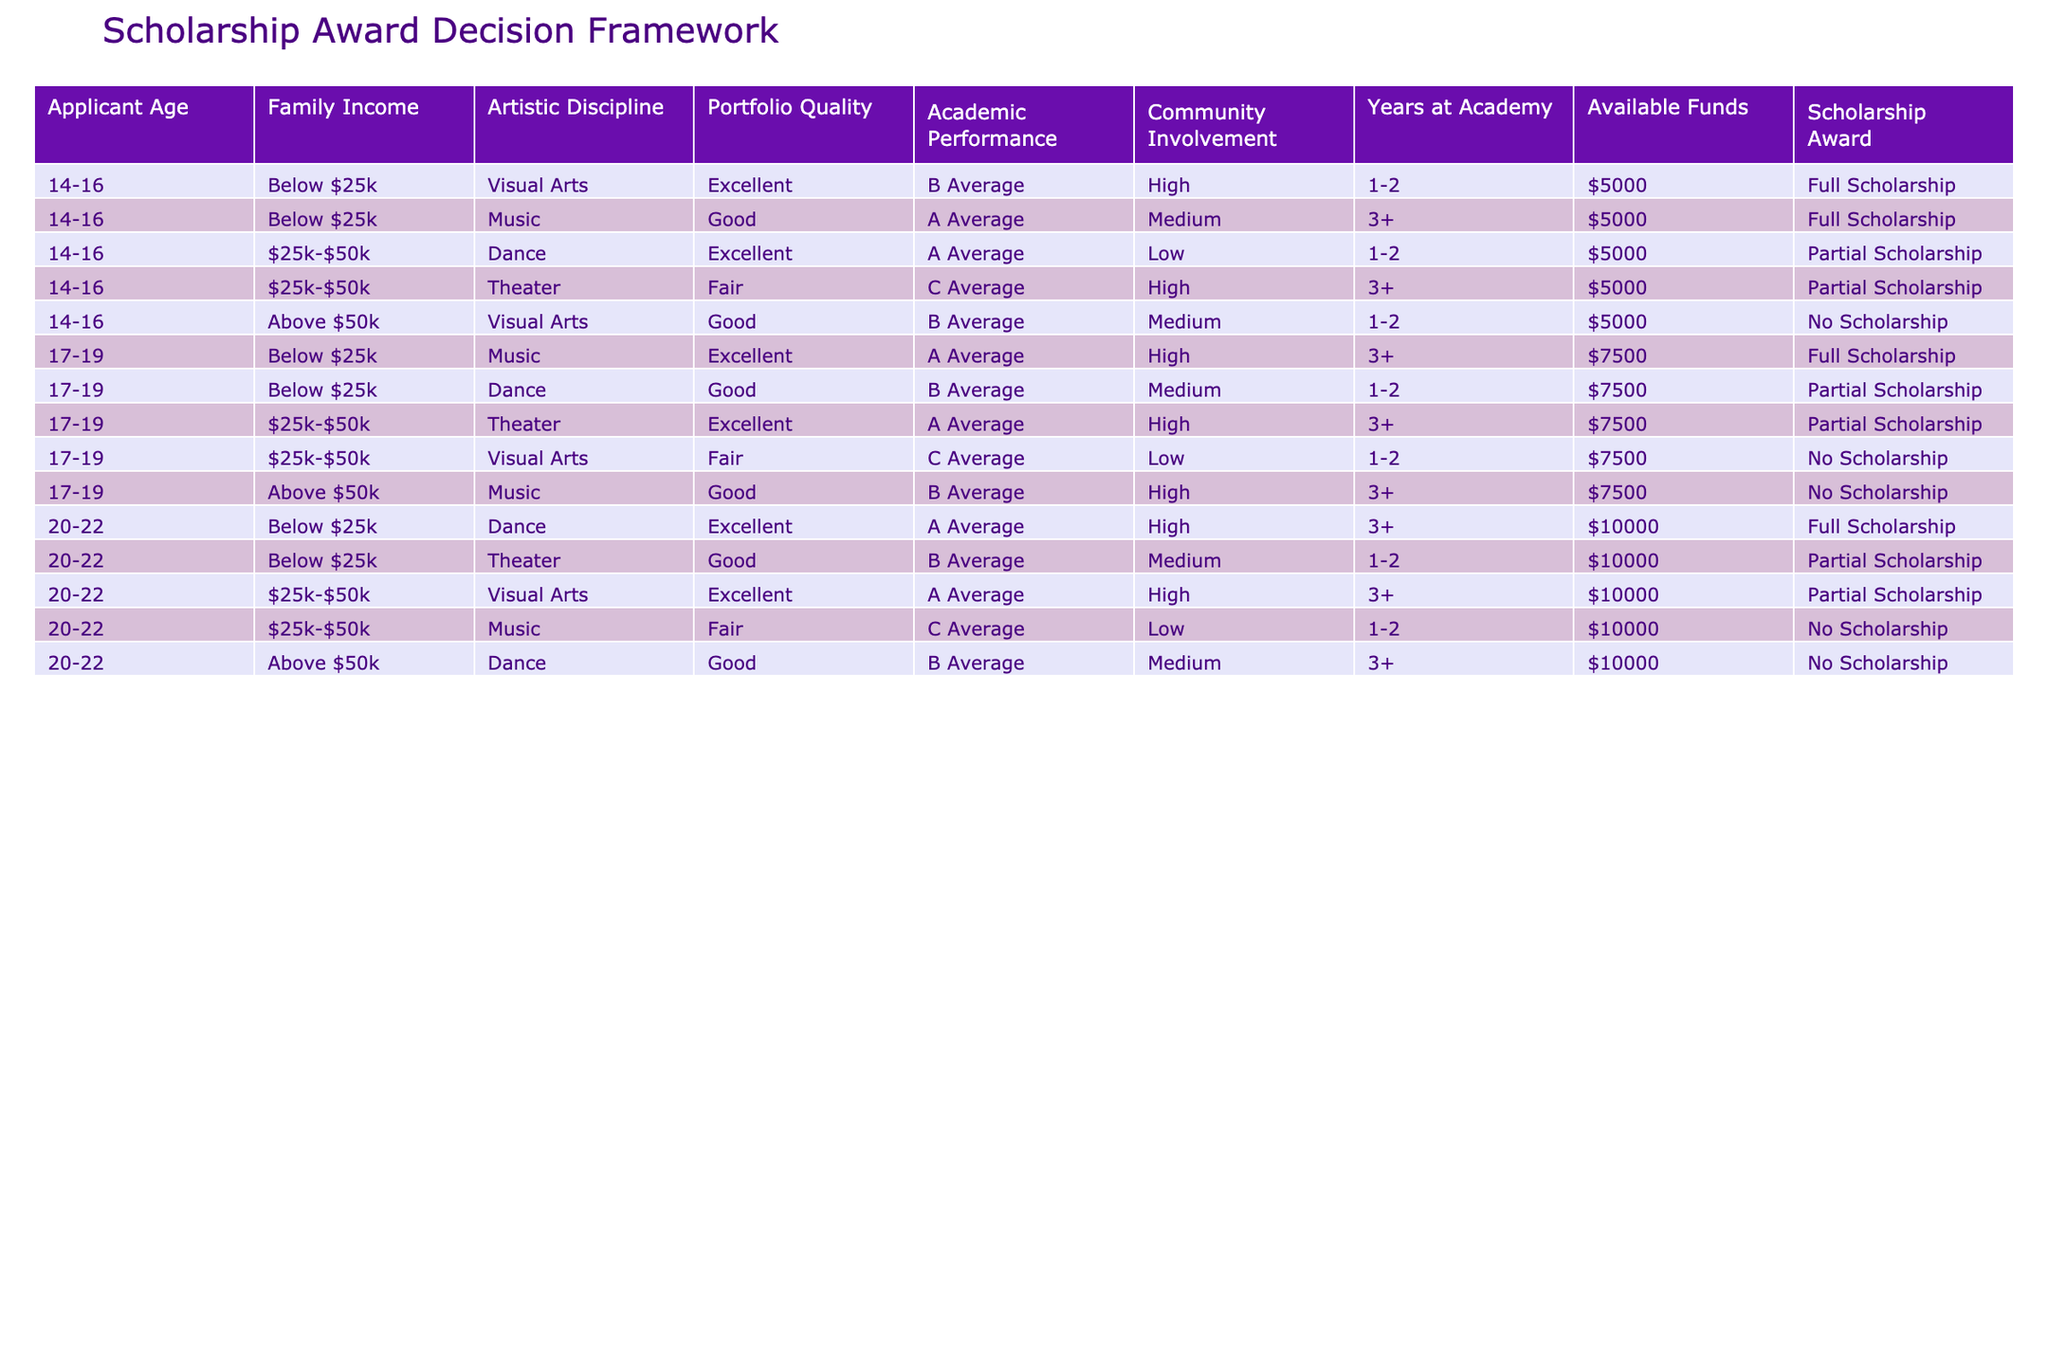What is the total number of full scholarships awarded? Counting the rows marked with "Full Scholarship" in the Scholarship Award column, there are three such rows: two for applicants aged 14-16 and one for applicants aged 20-22.
Answer: 3 What is the scholarship status for an applicant aged 17-19 with an Artistic Discipline in Dance? Looking at the row with the 17-19 age group for Dance, we find the corresponding scholarship status: “Good” portfolio quality and "B Average" academic performance leads to a "Partial Scholarship" award.
Answer: Partial Scholarship Is there any applicant aged 20-22 receiving a scholarship from a family earning over $50k? Reviewing the rows for applicants aged 20-22 with the family income over $50k reveals two entries, both of which show a "No Scholarship" status. Therefore, the answer is no.
Answer: No What is the average family income bracket of all applicants who received full scholarships? The full scholarship recipients are from two income brackets: "Below $25k" (2 applicants) and "Below $25k" (1 applicant) for the 20-22 age group. To find the average bracket that can be considered, assigning values, Below $25k is 1 and Above $50k is 3, then the average tends toward Below $25k.
Answer: Below $25k How many total partial scholarships were awarded to applicants aged 14-16? There are two rows for applicants aged 14-16 who received partial scholarships: one for Dance and the other for Theater. This gives a total of two partial scholarships for this age group.
Answer: 2 Did any applicant aged 17-19 with a "Fair" portfolio quality receive a scholarship? Looking closely at the 17-19 age group entries, we find one applicant with a "Fair" portfolio quality (Visual Arts). The corresponding scholarship award is "No Scholarship," making the answer no.
Answer: No 